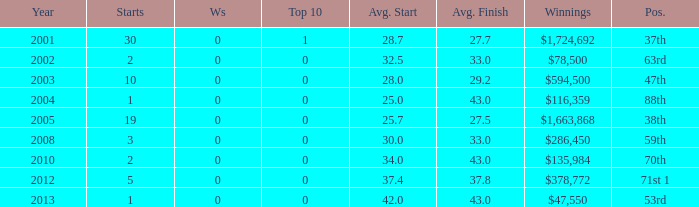How many wins for average start less than 25? 0.0. 